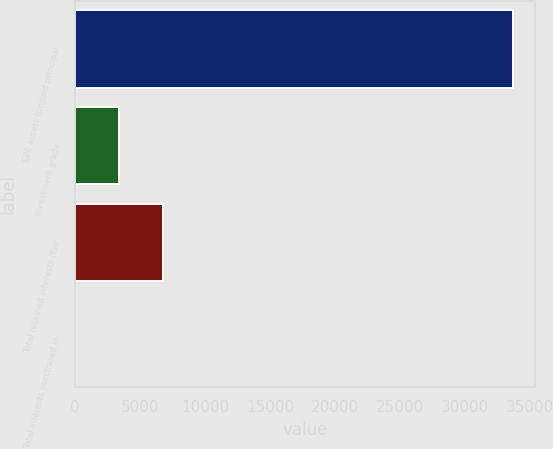Convert chart to OTSL. <chart><loc_0><loc_0><loc_500><loc_500><bar_chart><fcel>SPE assets (unpaid principal<fcel>Investment grade<fcel>Total retained interests (fair<fcel>Total interests purchased in<nl><fcel>33728<fcel>3390.8<fcel>6761.6<fcel>20<nl></chart> 